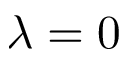Convert formula to latex. <formula><loc_0><loc_0><loc_500><loc_500>\lambda = 0</formula> 